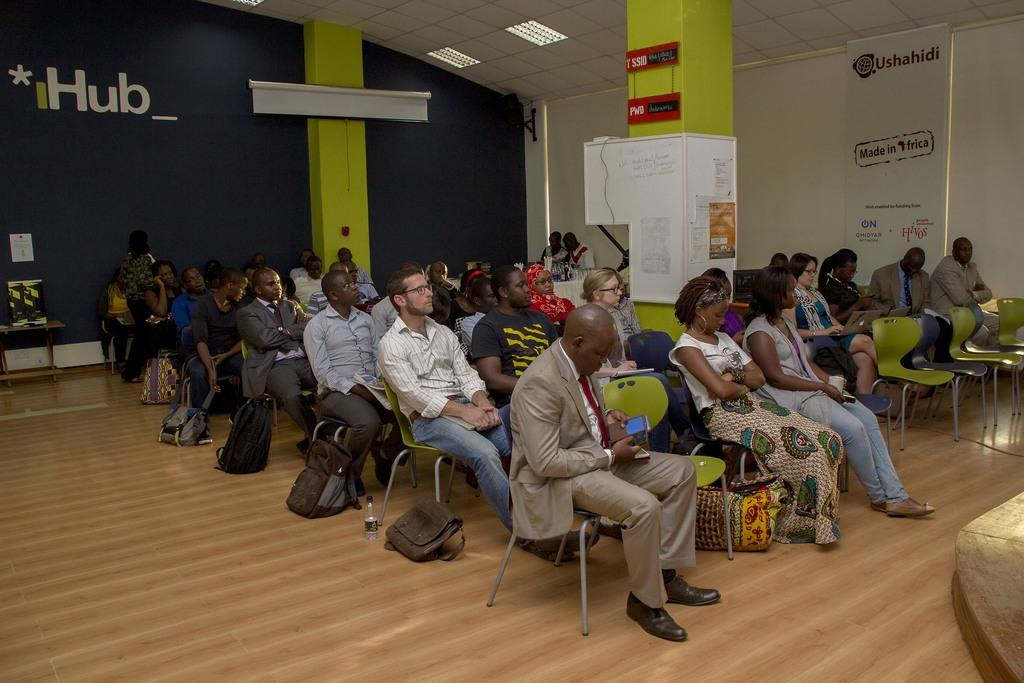What type of setting is shown in the image? The image depicts a room. How many people are present in the room? There are multiple persons in the room. What are the persons doing in the image? The persons are sitting on chairs. What can be seen in the background of the image? There is a wall visible in the background of the image. What type of quill is being used by the persons in the image? There is no quill present in the image; the persons are sitting on chairs. What is the aftermath of the battle that took place in the room? There is no battle depicted in the image; it shows multiple persons sitting on chairs in a room. 